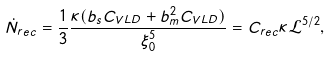<formula> <loc_0><loc_0><loc_500><loc_500>\dot { N } _ { r e c } = \frac { 1 } { 3 } \frac { \kappa ( b _ { s } C _ { V L D } + b _ { m } ^ { 2 } C _ { V L D } ) } { \xi _ { 0 } ^ { 5 } } = C _ { r e c } \kappa \mathcal { L } ^ { 5 / 2 } ,</formula> 